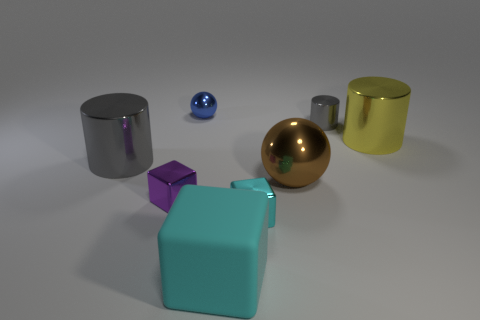Is there any other thing that has the same material as the large cyan thing?
Your response must be concise. No. There is a blue object that is the same shape as the big brown metallic thing; what size is it?
Keep it short and to the point. Small. There is a cyan matte cube; is it the same size as the gray metal object that is in front of the yellow cylinder?
Offer a very short reply. Yes. Is there a gray thing that is to the left of the metallic block that is right of the cyan matte object?
Your response must be concise. Yes. There is a blue object that is behind the brown ball; what is its shape?
Your answer should be compact. Sphere. What is the material of the other object that is the same color as the large rubber object?
Keep it short and to the point. Metal. There is a large cylinder behind the gray object in front of the tiny gray shiny object; what is its color?
Give a very brief answer. Yellow. Do the purple thing and the yellow metallic cylinder have the same size?
Provide a short and direct response. No. There is a large thing that is the same shape as the tiny blue thing; what material is it?
Make the answer very short. Metal. What number of blocks have the same size as the blue metal ball?
Your answer should be very brief. 2. 